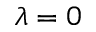Convert formula to latex. <formula><loc_0><loc_0><loc_500><loc_500>\lambda = 0</formula> 